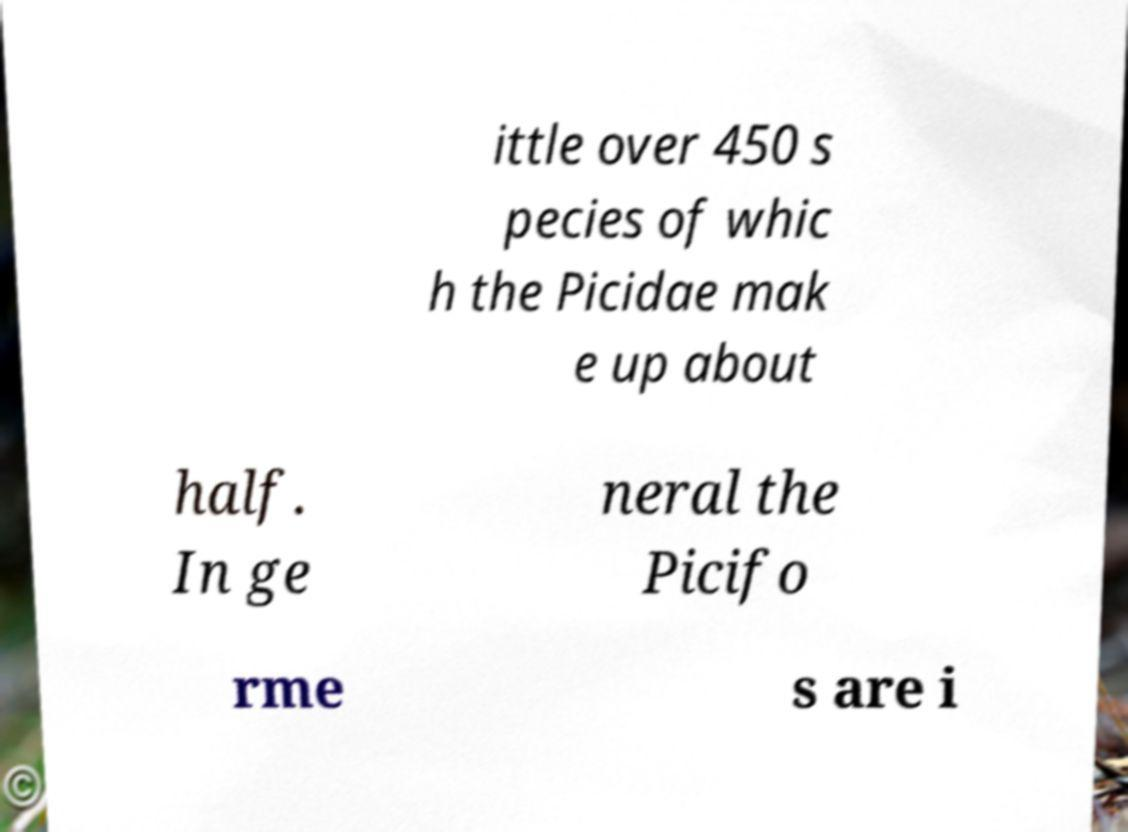Could you assist in decoding the text presented in this image and type it out clearly? ittle over 450 s pecies of whic h the Picidae mak e up about half. In ge neral the Picifo rme s are i 